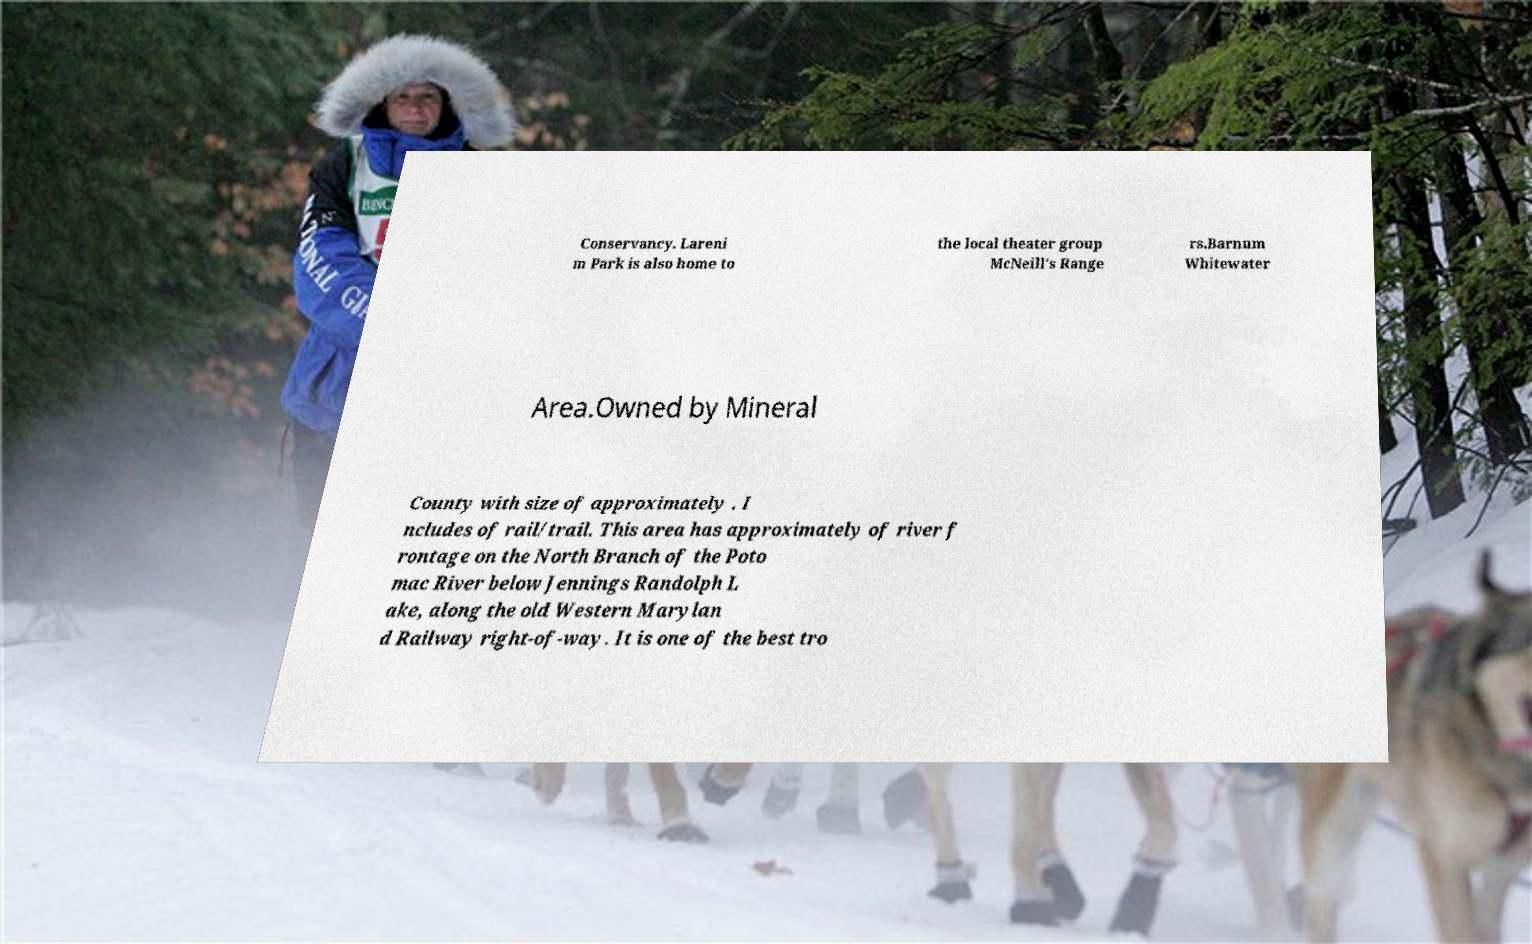Can you accurately transcribe the text from the provided image for me? Conservancy. Lareni m Park is also home to the local theater group McNeill's Range rs.Barnum Whitewater Area.Owned by Mineral County with size of approximately . I ncludes of rail/trail. This area has approximately of river f rontage on the North Branch of the Poto mac River below Jennings Randolph L ake, along the old Western Marylan d Railway right-of-way. It is one of the best tro 